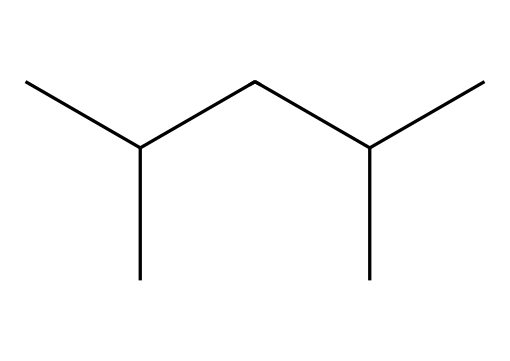what is the total number of carbon atoms in the compound? The SMILES representation shows "CC(C)CC(C)C", where each 'C' represents a carbon atom. Counting them, there are 8 carbon atoms in total.
Answer: 8 how many branches does this compound have? In the chemical structure, the notation "C(C)" indicates branching. There are two instances of branching present (each denoted by a branch from a carbon to another carbon), making a total of 2 branches.
Answer: 2 what type of chemical structure is represented here? The presence of only carbon and hydrogen atoms in the SMILES representation indicates that this is a hydrocarbon, specifically an alkane due to the single bonds between carbon atoms.
Answer: alkane what is the molecular formula of this compound? Counting the carbon (C) and hydrogen (H) atoms gives C8H18, as there are 8 carbon atoms and 18 hydrogen atoms linked to them according to the alkane formula (CnH2n+2).
Answer: C8H18 does this compound have any functional groups? The representation "CC(C)CC(C)C" shows only carbon and hydrogen atoms without any heteroatoms or distinct functional group indicators, confirming that there are no functional groups present in this compound.
Answer: no 